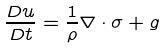Convert formula to latex. <formula><loc_0><loc_0><loc_500><loc_500>\frac { D u } { D t } = \frac { 1 } { \rho } \nabla \cdot \sigma + g</formula> 